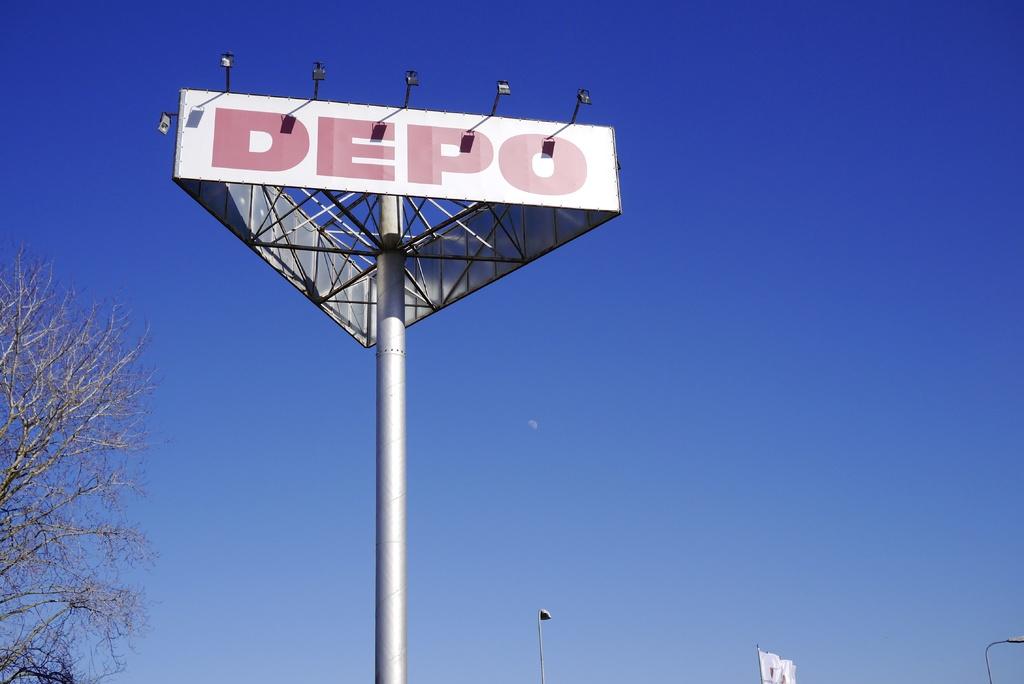What is the name of the pole?
Offer a very short reply. Depo. 